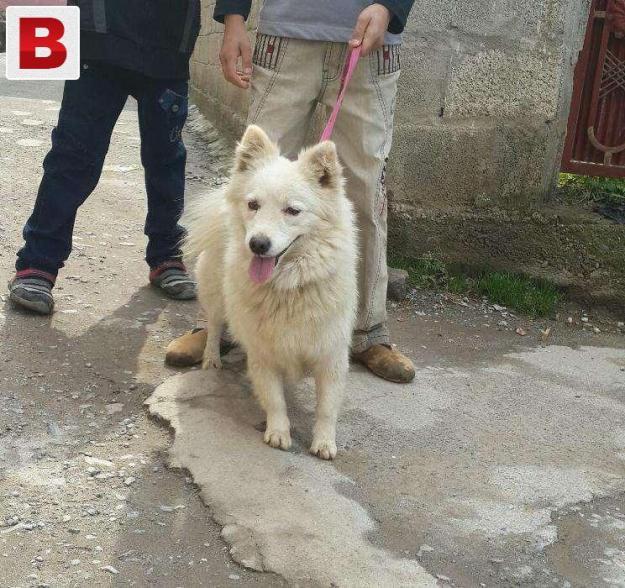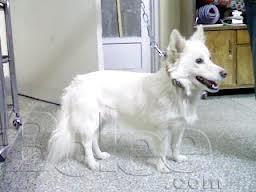The first image is the image on the left, the second image is the image on the right. Considering the images on both sides, is "One of the dogs is lying down on grass." valid? Answer yes or no. No. The first image is the image on the left, the second image is the image on the right. Examine the images to the left and right. Is the description "The huge white dogs are laying in the lush green grass." accurate? Answer yes or no. No. 